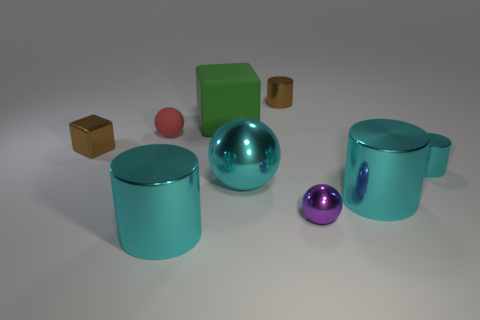Are there any cyan metal balls?
Provide a succinct answer. Yes. How many matte things have the same color as the big shiny sphere?
Keep it short and to the point. 0. What material is the tiny cylinder that is the same color as the big metal ball?
Your answer should be very brief. Metal. There is a cylinder right of the large thing that is to the right of the small shiny sphere; what size is it?
Offer a terse response. Small. Are there any large cyan cylinders made of the same material as the tiny red object?
Provide a succinct answer. No. There is a cyan ball that is the same size as the green block; what is it made of?
Offer a terse response. Metal. Is the color of the small metal thing behind the green cube the same as the block in front of the big green block?
Your answer should be compact. Yes. Are there any cubes that are right of the brown metallic thing behind the big green cube?
Your response must be concise. No. Is the shape of the large cyan object to the right of the purple shiny ball the same as the big rubber object on the right side of the red rubber object?
Offer a very short reply. No. Are the sphere that is behind the large cyan ball and the brown thing that is on the left side of the large block made of the same material?
Give a very brief answer. No. 